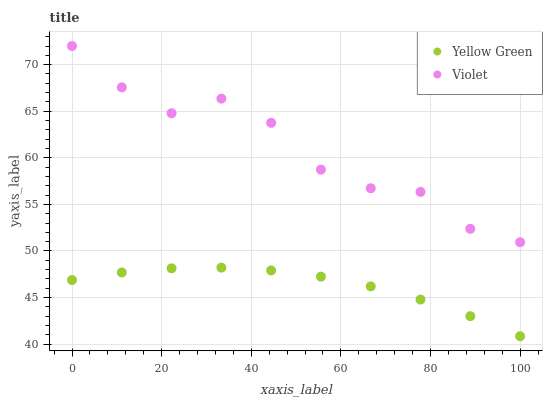Does Yellow Green have the minimum area under the curve?
Answer yes or no. Yes. Does Violet have the maximum area under the curve?
Answer yes or no. Yes. Does Violet have the minimum area under the curve?
Answer yes or no. No. Is Yellow Green the smoothest?
Answer yes or no. Yes. Is Violet the roughest?
Answer yes or no. Yes. Is Violet the smoothest?
Answer yes or no. No. Does Yellow Green have the lowest value?
Answer yes or no. Yes. Does Violet have the lowest value?
Answer yes or no. No. Does Violet have the highest value?
Answer yes or no. Yes. Is Yellow Green less than Violet?
Answer yes or no. Yes. Is Violet greater than Yellow Green?
Answer yes or no. Yes. Does Yellow Green intersect Violet?
Answer yes or no. No. 